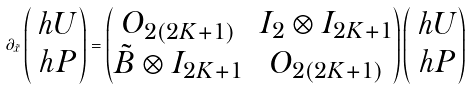<formula> <loc_0><loc_0><loc_500><loc_500>\partial _ { \tilde { x } } \begin{pmatrix} \ h U \\ \ h P \end{pmatrix} = \begin{pmatrix} O _ { 2 ( 2 K + 1 ) } & I _ { 2 } \otimes I _ { 2 K + 1 } \\ \tilde { B } \otimes I _ { 2 K + 1 } & O _ { 2 ( 2 K + 1 ) } \end{pmatrix} \begin{pmatrix} \ h U \\ \ h P \end{pmatrix}</formula> 